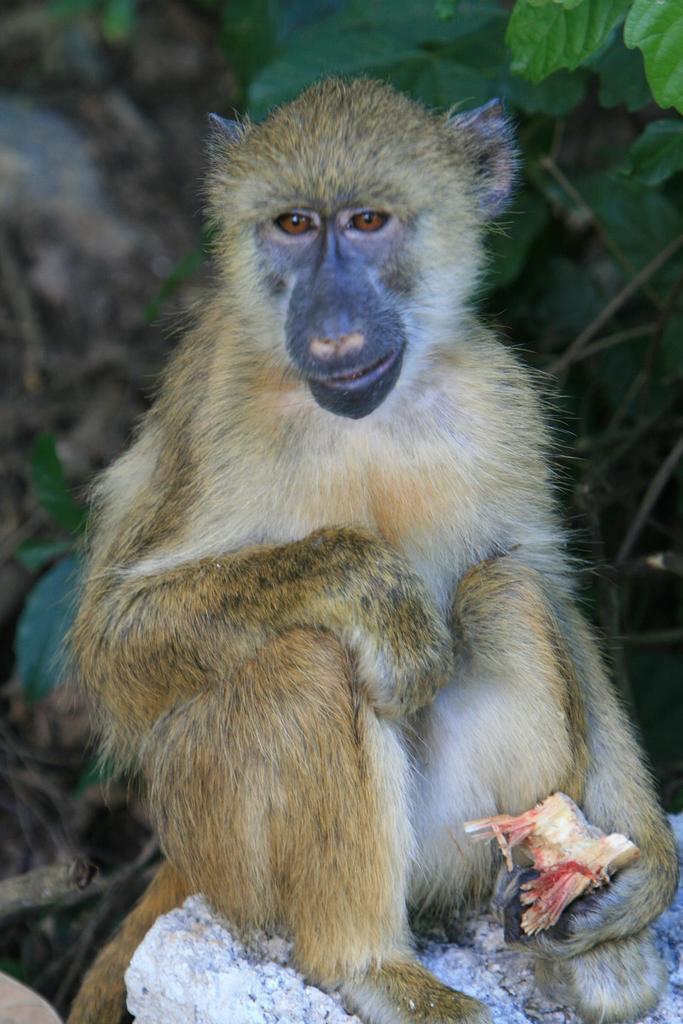Please provide a concise description of this image. In the middle of the image we can see a monkey holding something in the hand and sitting on a stone. Behind the monkey there is a tree. 